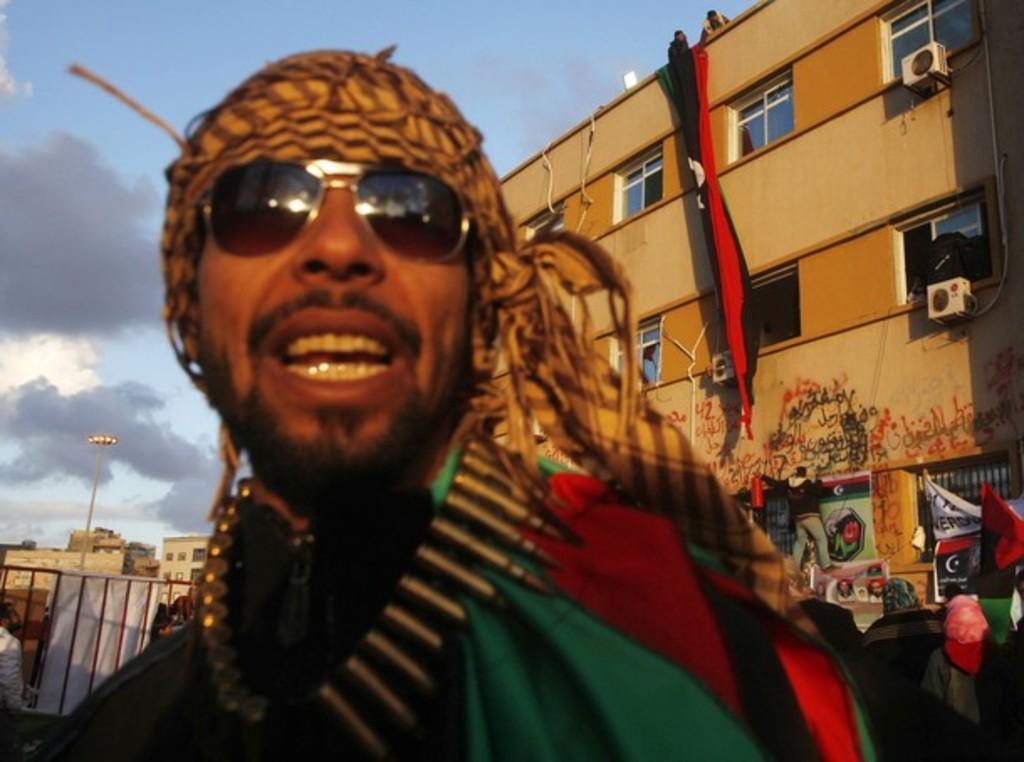Describe this image in one or two sentences. In the front of the image I can see a person wore goggles. In the background of the image there are buildings, light pole, banners, grille, people, cloudy sky and objects.   